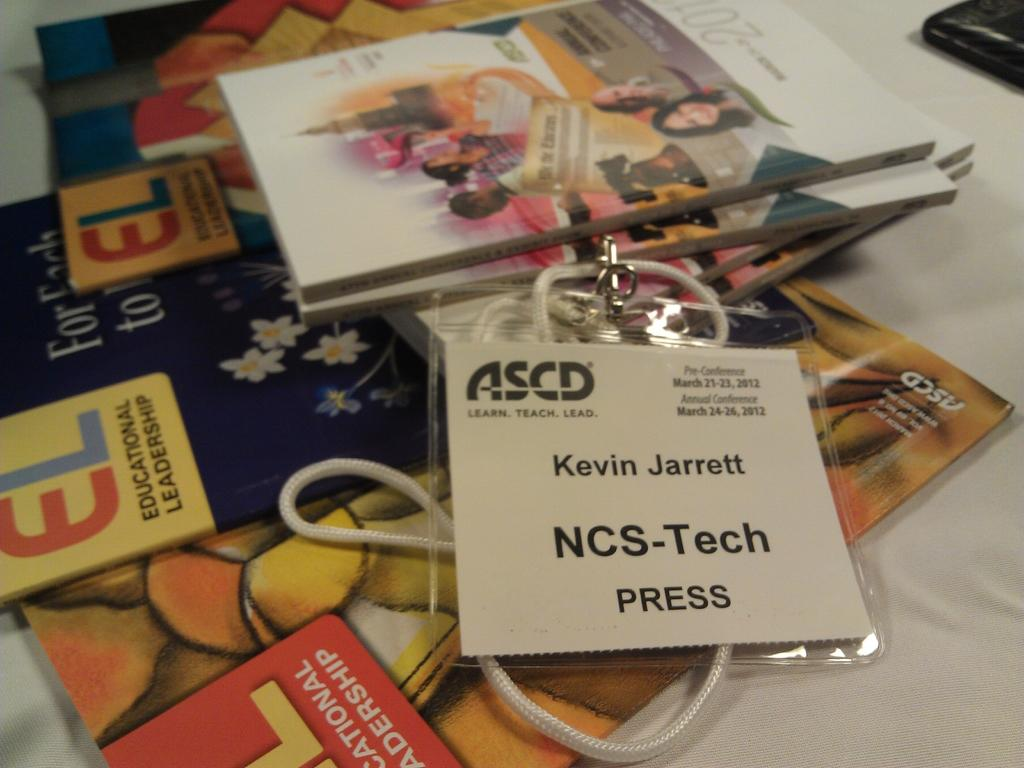<image>
Provide a brief description of the given image. A white table with magazines and a press pass belonging to NCS-Tech Kevin Jarrett. 